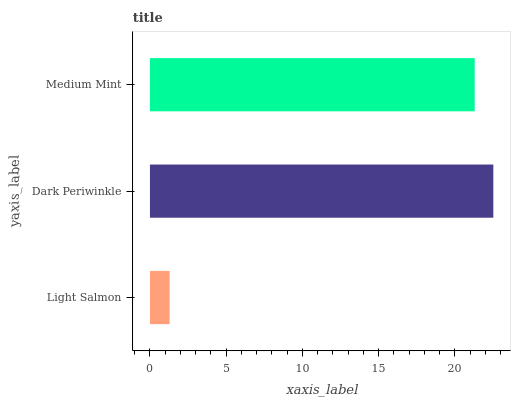Is Light Salmon the minimum?
Answer yes or no. Yes. Is Dark Periwinkle the maximum?
Answer yes or no. Yes. Is Medium Mint the minimum?
Answer yes or no. No. Is Medium Mint the maximum?
Answer yes or no. No. Is Dark Periwinkle greater than Medium Mint?
Answer yes or no. Yes. Is Medium Mint less than Dark Periwinkle?
Answer yes or no. Yes. Is Medium Mint greater than Dark Periwinkle?
Answer yes or no. No. Is Dark Periwinkle less than Medium Mint?
Answer yes or no. No. Is Medium Mint the high median?
Answer yes or no. Yes. Is Medium Mint the low median?
Answer yes or no. Yes. Is Dark Periwinkle the high median?
Answer yes or no. No. Is Dark Periwinkle the low median?
Answer yes or no. No. 